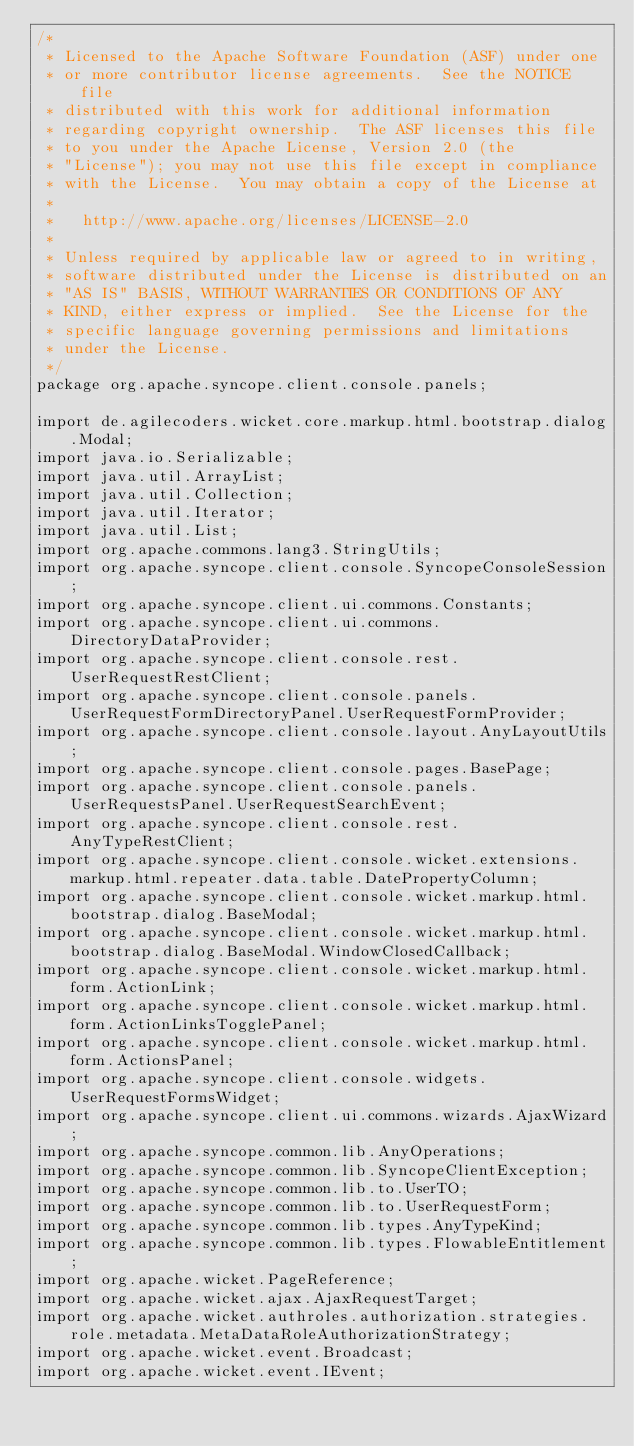Convert code to text. <code><loc_0><loc_0><loc_500><loc_500><_Java_>/*
 * Licensed to the Apache Software Foundation (ASF) under one
 * or more contributor license agreements.  See the NOTICE file
 * distributed with this work for additional information
 * regarding copyright ownership.  The ASF licenses this file
 * to you under the Apache License, Version 2.0 (the
 * "License"); you may not use this file except in compliance
 * with the License.  You may obtain a copy of the License at
 *
 *   http://www.apache.org/licenses/LICENSE-2.0
 *
 * Unless required by applicable law or agreed to in writing,
 * software distributed under the License is distributed on an
 * "AS IS" BASIS, WITHOUT WARRANTIES OR CONDITIONS OF ANY
 * KIND, either express or implied.  See the License for the
 * specific language governing permissions and limitations
 * under the License.
 */
package org.apache.syncope.client.console.panels;

import de.agilecoders.wicket.core.markup.html.bootstrap.dialog.Modal;
import java.io.Serializable;
import java.util.ArrayList;
import java.util.Collection;
import java.util.Iterator;
import java.util.List;
import org.apache.commons.lang3.StringUtils;
import org.apache.syncope.client.console.SyncopeConsoleSession;
import org.apache.syncope.client.ui.commons.Constants;
import org.apache.syncope.client.ui.commons.DirectoryDataProvider;
import org.apache.syncope.client.console.rest.UserRequestRestClient;
import org.apache.syncope.client.console.panels.UserRequestFormDirectoryPanel.UserRequestFormProvider;
import org.apache.syncope.client.console.layout.AnyLayoutUtils;
import org.apache.syncope.client.console.pages.BasePage;
import org.apache.syncope.client.console.panels.UserRequestsPanel.UserRequestSearchEvent;
import org.apache.syncope.client.console.rest.AnyTypeRestClient;
import org.apache.syncope.client.console.wicket.extensions.markup.html.repeater.data.table.DatePropertyColumn;
import org.apache.syncope.client.console.wicket.markup.html.bootstrap.dialog.BaseModal;
import org.apache.syncope.client.console.wicket.markup.html.bootstrap.dialog.BaseModal.WindowClosedCallback;
import org.apache.syncope.client.console.wicket.markup.html.form.ActionLink;
import org.apache.syncope.client.console.wicket.markup.html.form.ActionLinksTogglePanel;
import org.apache.syncope.client.console.wicket.markup.html.form.ActionsPanel;
import org.apache.syncope.client.console.widgets.UserRequestFormsWidget;
import org.apache.syncope.client.ui.commons.wizards.AjaxWizard;
import org.apache.syncope.common.lib.AnyOperations;
import org.apache.syncope.common.lib.SyncopeClientException;
import org.apache.syncope.common.lib.to.UserTO;
import org.apache.syncope.common.lib.to.UserRequestForm;
import org.apache.syncope.common.lib.types.AnyTypeKind;
import org.apache.syncope.common.lib.types.FlowableEntitlement;
import org.apache.wicket.PageReference;
import org.apache.wicket.ajax.AjaxRequestTarget;
import org.apache.wicket.authroles.authorization.strategies.role.metadata.MetaDataRoleAuthorizationStrategy;
import org.apache.wicket.event.Broadcast;
import org.apache.wicket.event.IEvent;</code> 